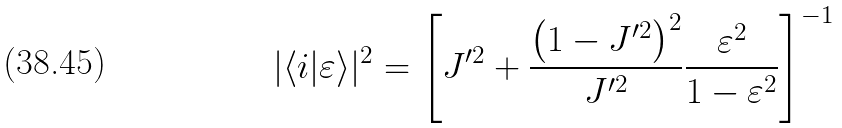<formula> <loc_0><loc_0><loc_500><loc_500>| \langle i | \varepsilon \rangle | ^ { 2 } = \left [ J ^ { \prime 2 } + \frac { \left ( 1 - J ^ { \prime 2 } \right ) ^ { 2 } } { J ^ { \prime 2 } } \frac { \varepsilon ^ { 2 } } { 1 - \varepsilon ^ { 2 } } \right ] ^ { - 1 }</formula> 